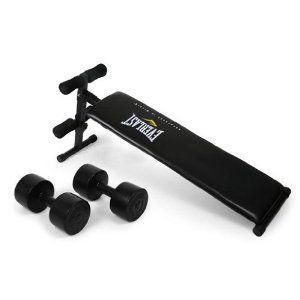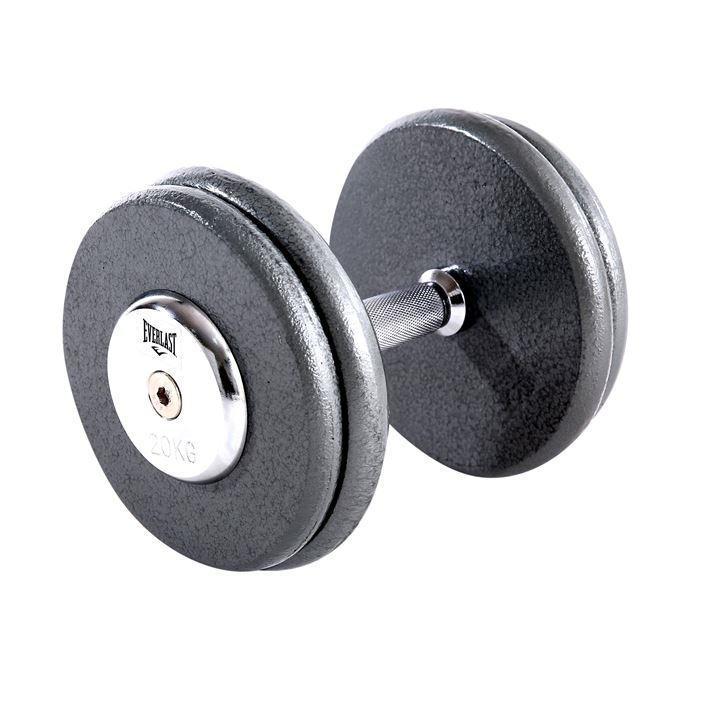The first image is the image on the left, the second image is the image on the right. Assess this claim about the two images: "The left image contains two dumbells without pipe sticking out.". Correct or not? Answer yes or no. Yes. The first image is the image on the left, the second image is the image on the right. Assess this claim about the two images: "There are exactly three dumbbells.". Correct or not? Answer yes or no. Yes. 